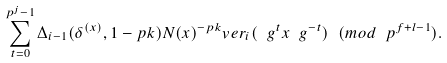Convert formula to latex. <formula><loc_0><loc_0><loc_500><loc_500>\sum _ { t = 0 } ^ { p ^ { j } - 1 } \Delta _ { i - 1 } ( \delta ^ { ( x ) } , 1 - p k ) N ( x ) ^ { - p k } v e r _ { i } ( \ g ^ { t } x \ g ^ { - t } ) \ ( m o d \ p ^ { f + l - 1 } ) .</formula> 